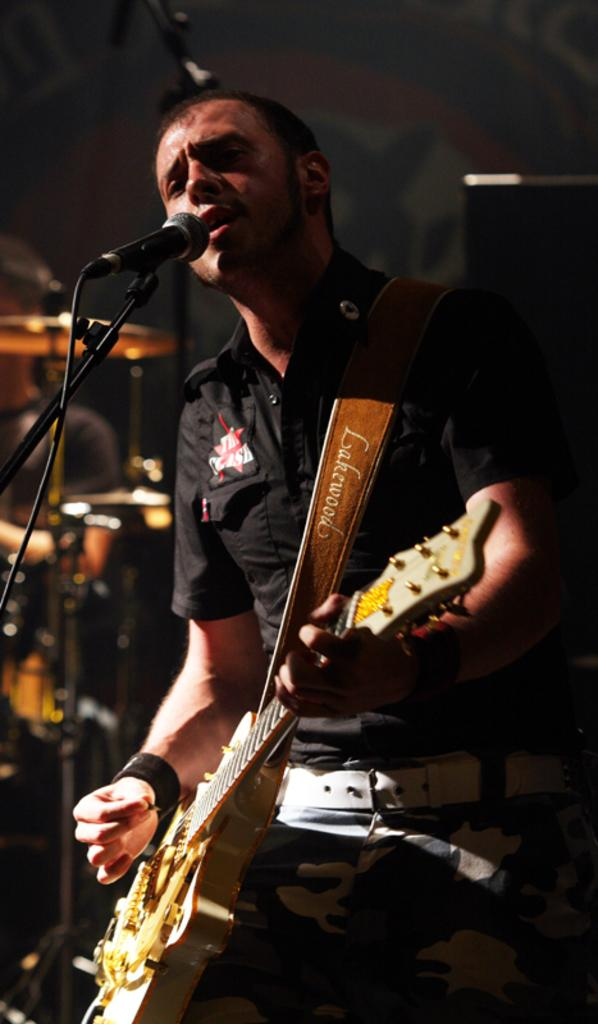What is the main subject of the image? There is a person in the image. What is the person doing in the image? The person is standing and holding a guitar in his hand. What equipment is present in front of the person? There is a microphone with a stand in front of the person. Can you describe the background of the image? The background of the image is slightly blurry. What type of process is being carried out by the needle in the image? There is no needle present in the image. 